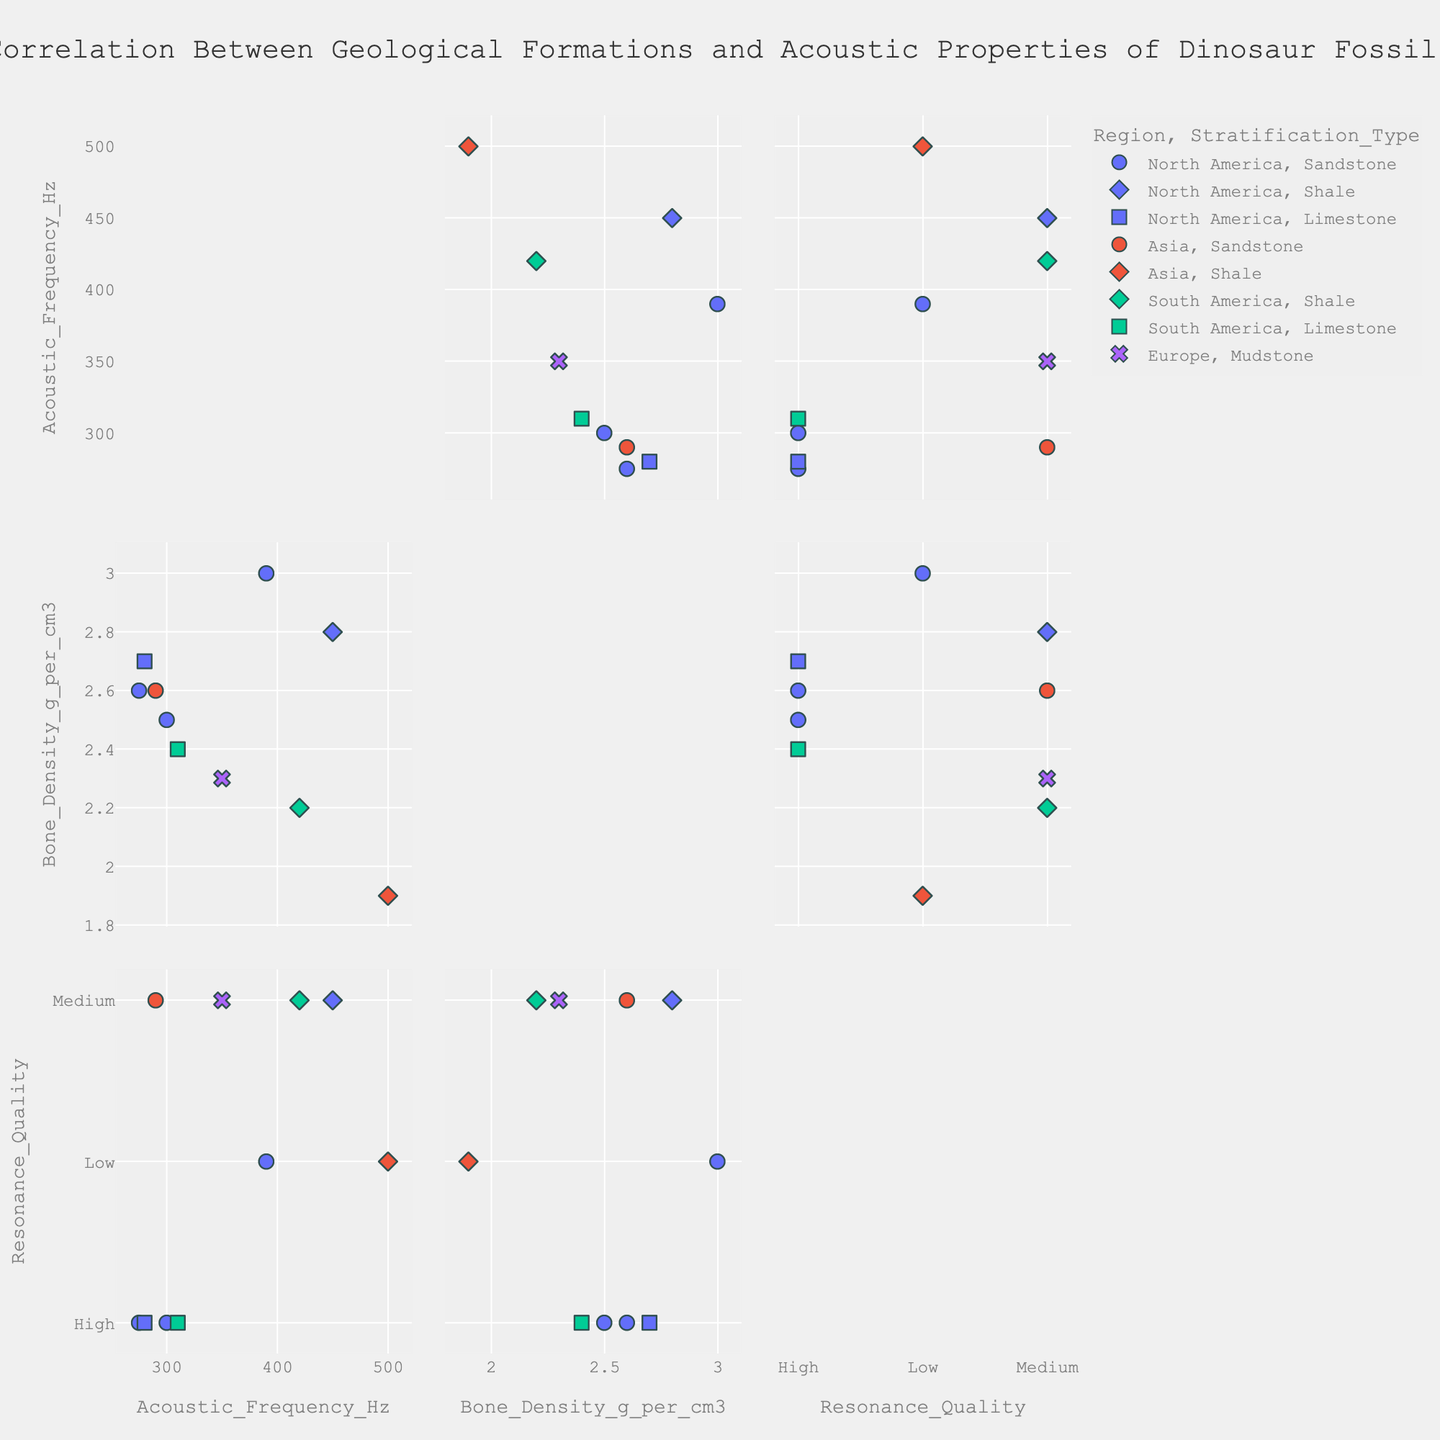What is the title of the figure? The title is usually positioned at the top of the figure. Referring to the custom title in the given code, it is mentioned directly.
Answer: "Correlation Between Geological Formations and Acoustic Properties of Dinosaur Fossils" How many regions are represented in this figure? By looking at the scatter plot matrix, one can identify the regions through the color coding. The colors and regions provided in the data include North America, Asia, South America, and Europe.
Answer: 4 Which formation has the highest Bone Density, and what is its value? To find the highest Bone Density, examine the scatter plot matrix and look for the maximum value on the Bone Density axis. By referring to the provided data, the highest value is 3.0 g/cm³ in the Yale Formation.
Answer: Yale Formation, 3.0 g/cm³ Is there a noticeable trend between Acoustic Frequency and Bone Density for any specific region? To answer this, observe the scatter plot cells that plot Acoustic Frequency against Bone Density. By examining the groups by region, one might notice trends. For example, higher frequencies are coupled with varying densities within regions.
Answer: Trends are varied within regions Which dinosaur species has the lowest Acoustic Frequency, and what is its value? To find the lowest value, look through the scatter plots representing Acoustic Frequency. From the data, Tyrannosaurus rex from the Hell Creek Formation has the lowest Acoustic Frequency at 280 Hz.
Answer: Tyrannosaurus rex, 280 Hz Is there any correlation between Resonance Quality and Bone Density for fossils found in Asia? By locating the scatter plot cells that graph Resonance Quality against Bone Density and isolating datapoints representing Asia (color-coded), one can observe correlations. For instance, in Asia, a lower Bone Density seems to have low to medium resonance quality.
Answer: Low Bone Density corresponds to low to medium resonance quality in Asia Which stratification types are represented in the Santana Formation in South America? Using the hover data from the scatter plot matrix when pointing to data points from the Santana Formation, one can see the represented stratification types. According to the data provided, the stratification type is Shale.
Answer: Shale Compare the Acoustic Frequency of fossils found in North America with those found in South America. Which region shows a wider range? By examining the scatter plots for Acoustic Frequency corresponding to North America and South America, one can see the range of values. North America spans from 275 Hz to 450 Hz whereas South America ranges from 310 Hz to 420 Hz.
Answer: North America Which region has the highest median Bone Density? Locate data points for each region plotted against Bone Density and find the median value. For North America, the values are (2.5, 2.7, 2.6, 3.0), for Asia (2.6, 1.9), for South America (2.4, 2.2), and Europe (2.3). The median for North America is 2.65, for Asia is 2.25, for South America is 2.3, and for Europe is 2.3. Hence, North America has the highest median Bone Density.
Answer: North America 